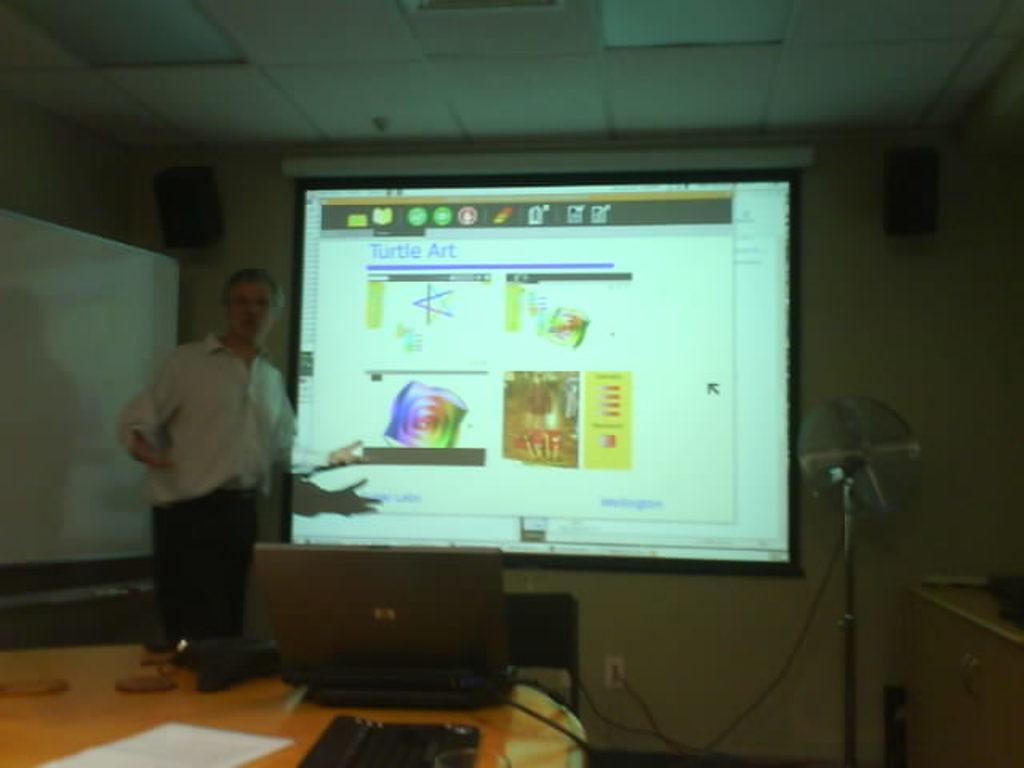In one or two sentences, can you explain what this image depicts? A screen on wall. This is a fan with stand. On this table there is a laptop, paper and keyboard. This person is standing in-front of this screen. On top there is a speaker. 